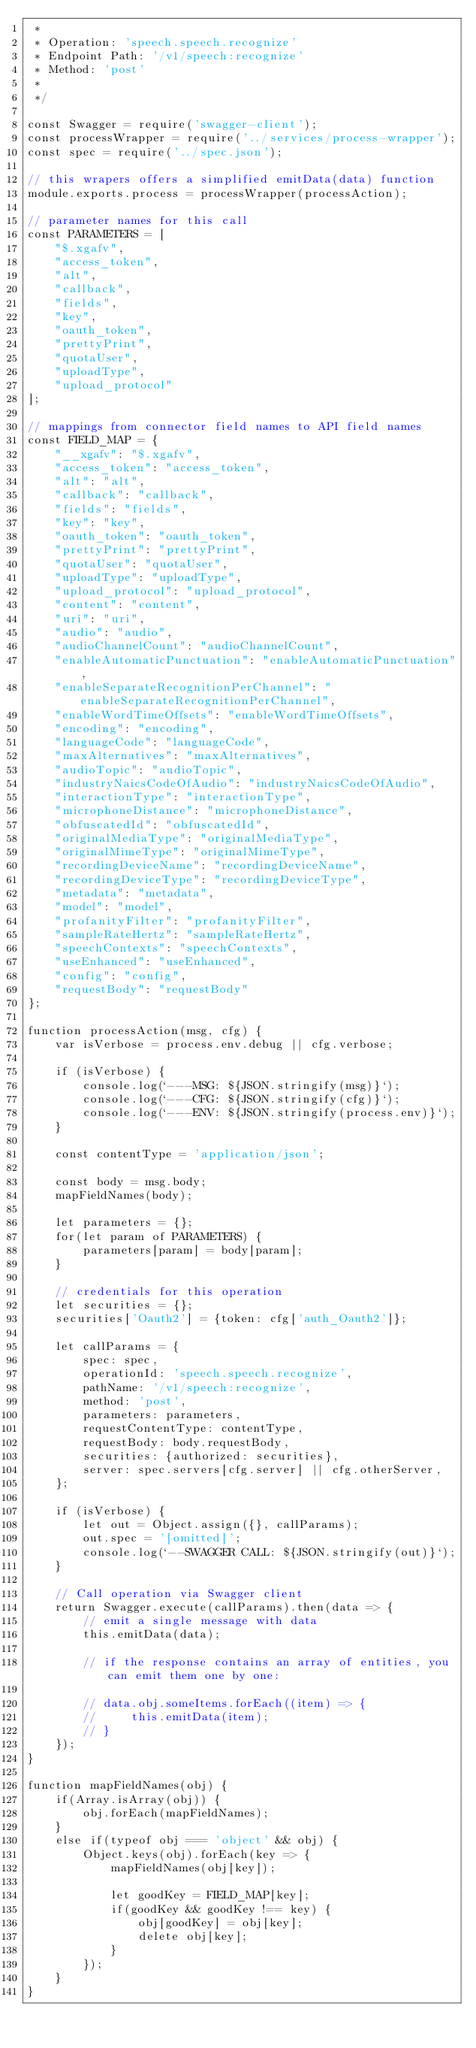<code> <loc_0><loc_0><loc_500><loc_500><_JavaScript_> *
 * Operation: 'speech.speech.recognize'
 * Endpoint Path: '/v1/speech:recognize'
 * Method: 'post'
 *
 */

const Swagger = require('swagger-client');
const processWrapper = require('../services/process-wrapper');
const spec = require('../spec.json');

// this wrapers offers a simplified emitData(data) function
module.exports.process = processWrapper(processAction);

// parameter names for this call
const PARAMETERS = [
    "$.xgafv",
    "access_token",
    "alt",
    "callback",
    "fields",
    "key",
    "oauth_token",
    "prettyPrint",
    "quotaUser",
    "uploadType",
    "upload_protocol"
];

// mappings from connector field names to API field names
const FIELD_MAP = {
    "__xgafv": "$.xgafv",
    "access_token": "access_token",
    "alt": "alt",
    "callback": "callback",
    "fields": "fields",
    "key": "key",
    "oauth_token": "oauth_token",
    "prettyPrint": "prettyPrint",
    "quotaUser": "quotaUser",
    "uploadType": "uploadType",
    "upload_protocol": "upload_protocol",
    "content": "content",
    "uri": "uri",
    "audio": "audio",
    "audioChannelCount": "audioChannelCount",
    "enableAutomaticPunctuation": "enableAutomaticPunctuation",
    "enableSeparateRecognitionPerChannel": "enableSeparateRecognitionPerChannel",
    "enableWordTimeOffsets": "enableWordTimeOffsets",
    "encoding": "encoding",
    "languageCode": "languageCode",
    "maxAlternatives": "maxAlternatives",
    "audioTopic": "audioTopic",
    "industryNaicsCodeOfAudio": "industryNaicsCodeOfAudio",
    "interactionType": "interactionType",
    "microphoneDistance": "microphoneDistance",
    "obfuscatedId": "obfuscatedId",
    "originalMediaType": "originalMediaType",
    "originalMimeType": "originalMimeType",
    "recordingDeviceName": "recordingDeviceName",
    "recordingDeviceType": "recordingDeviceType",
    "metadata": "metadata",
    "model": "model",
    "profanityFilter": "profanityFilter",
    "sampleRateHertz": "sampleRateHertz",
    "speechContexts": "speechContexts",
    "useEnhanced": "useEnhanced",
    "config": "config",
    "requestBody": "requestBody"
};

function processAction(msg, cfg) {
    var isVerbose = process.env.debug || cfg.verbose;

    if (isVerbose) {
        console.log(`---MSG: ${JSON.stringify(msg)}`);
        console.log(`---CFG: ${JSON.stringify(cfg)}`);
        console.log(`---ENV: ${JSON.stringify(process.env)}`);
    }

    const contentType = 'application/json';

    const body = msg.body;
    mapFieldNames(body);

    let parameters = {};
    for(let param of PARAMETERS) {
        parameters[param] = body[param];
    }

    // credentials for this operation
    let securities = {};
    securities['Oauth2'] = {token: cfg['auth_Oauth2']};

    let callParams = {
        spec: spec,
        operationId: 'speech.speech.recognize',
        pathName: '/v1/speech:recognize',
        method: 'post',
        parameters: parameters,
        requestContentType: contentType,
        requestBody: body.requestBody,
        securities: {authorized: securities},
        server: spec.servers[cfg.server] || cfg.otherServer,
    };

    if (isVerbose) {
        let out = Object.assign({}, callParams);
        out.spec = '[omitted]';
        console.log(`--SWAGGER CALL: ${JSON.stringify(out)}`);
    }

    // Call operation via Swagger client
    return Swagger.execute(callParams).then(data => {
        // emit a single message with data
        this.emitData(data);

        // if the response contains an array of entities, you can emit them one by one:

        // data.obj.someItems.forEach((item) => {
        //     this.emitData(item);
        // }
    });
}

function mapFieldNames(obj) {
    if(Array.isArray(obj)) {
        obj.forEach(mapFieldNames);
    }
    else if(typeof obj === 'object' && obj) {
        Object.keys(obj).forEach(key => {
            mapFieldNames(obj[key]);

            let goodKey = FIELD_MAP[key];
            if(goodKey && goodKey !== key) {
                obj[goodKey] = obj[key];
                delete obj[key];
            }
        });
    }
}</code> 